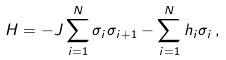<formula> <loc_0><loc_0><loc_500><loc_500>H = - J \sum _ { i = 1 } ^ { N } \sigma _ { i } \sigma _ { i + 1 } - \sum _ { i = 1 } ^ { N } h _ { i } \sigma _ { i } \, ,</formula> 